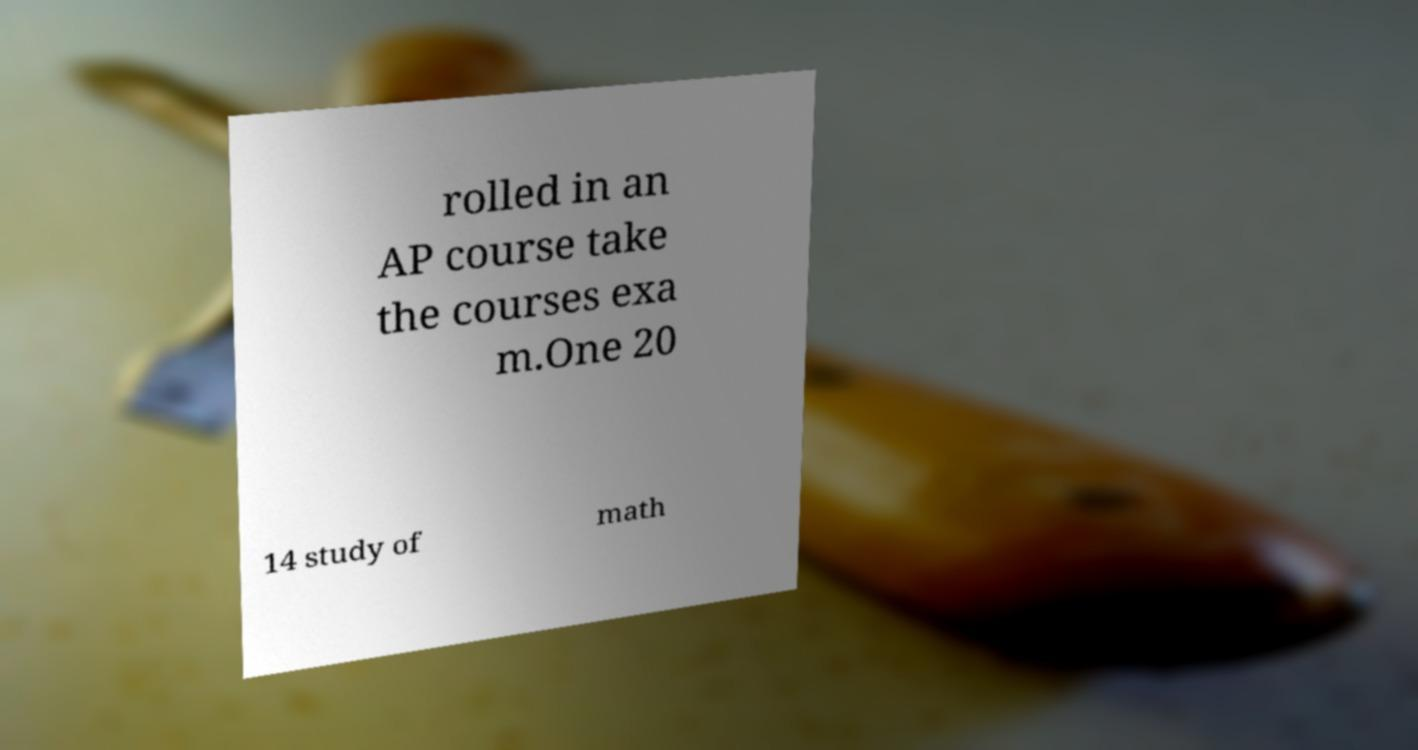Could you extract and type out the text from this image? rolled in an AP course take the courses exa m.One 20 14 study of math 